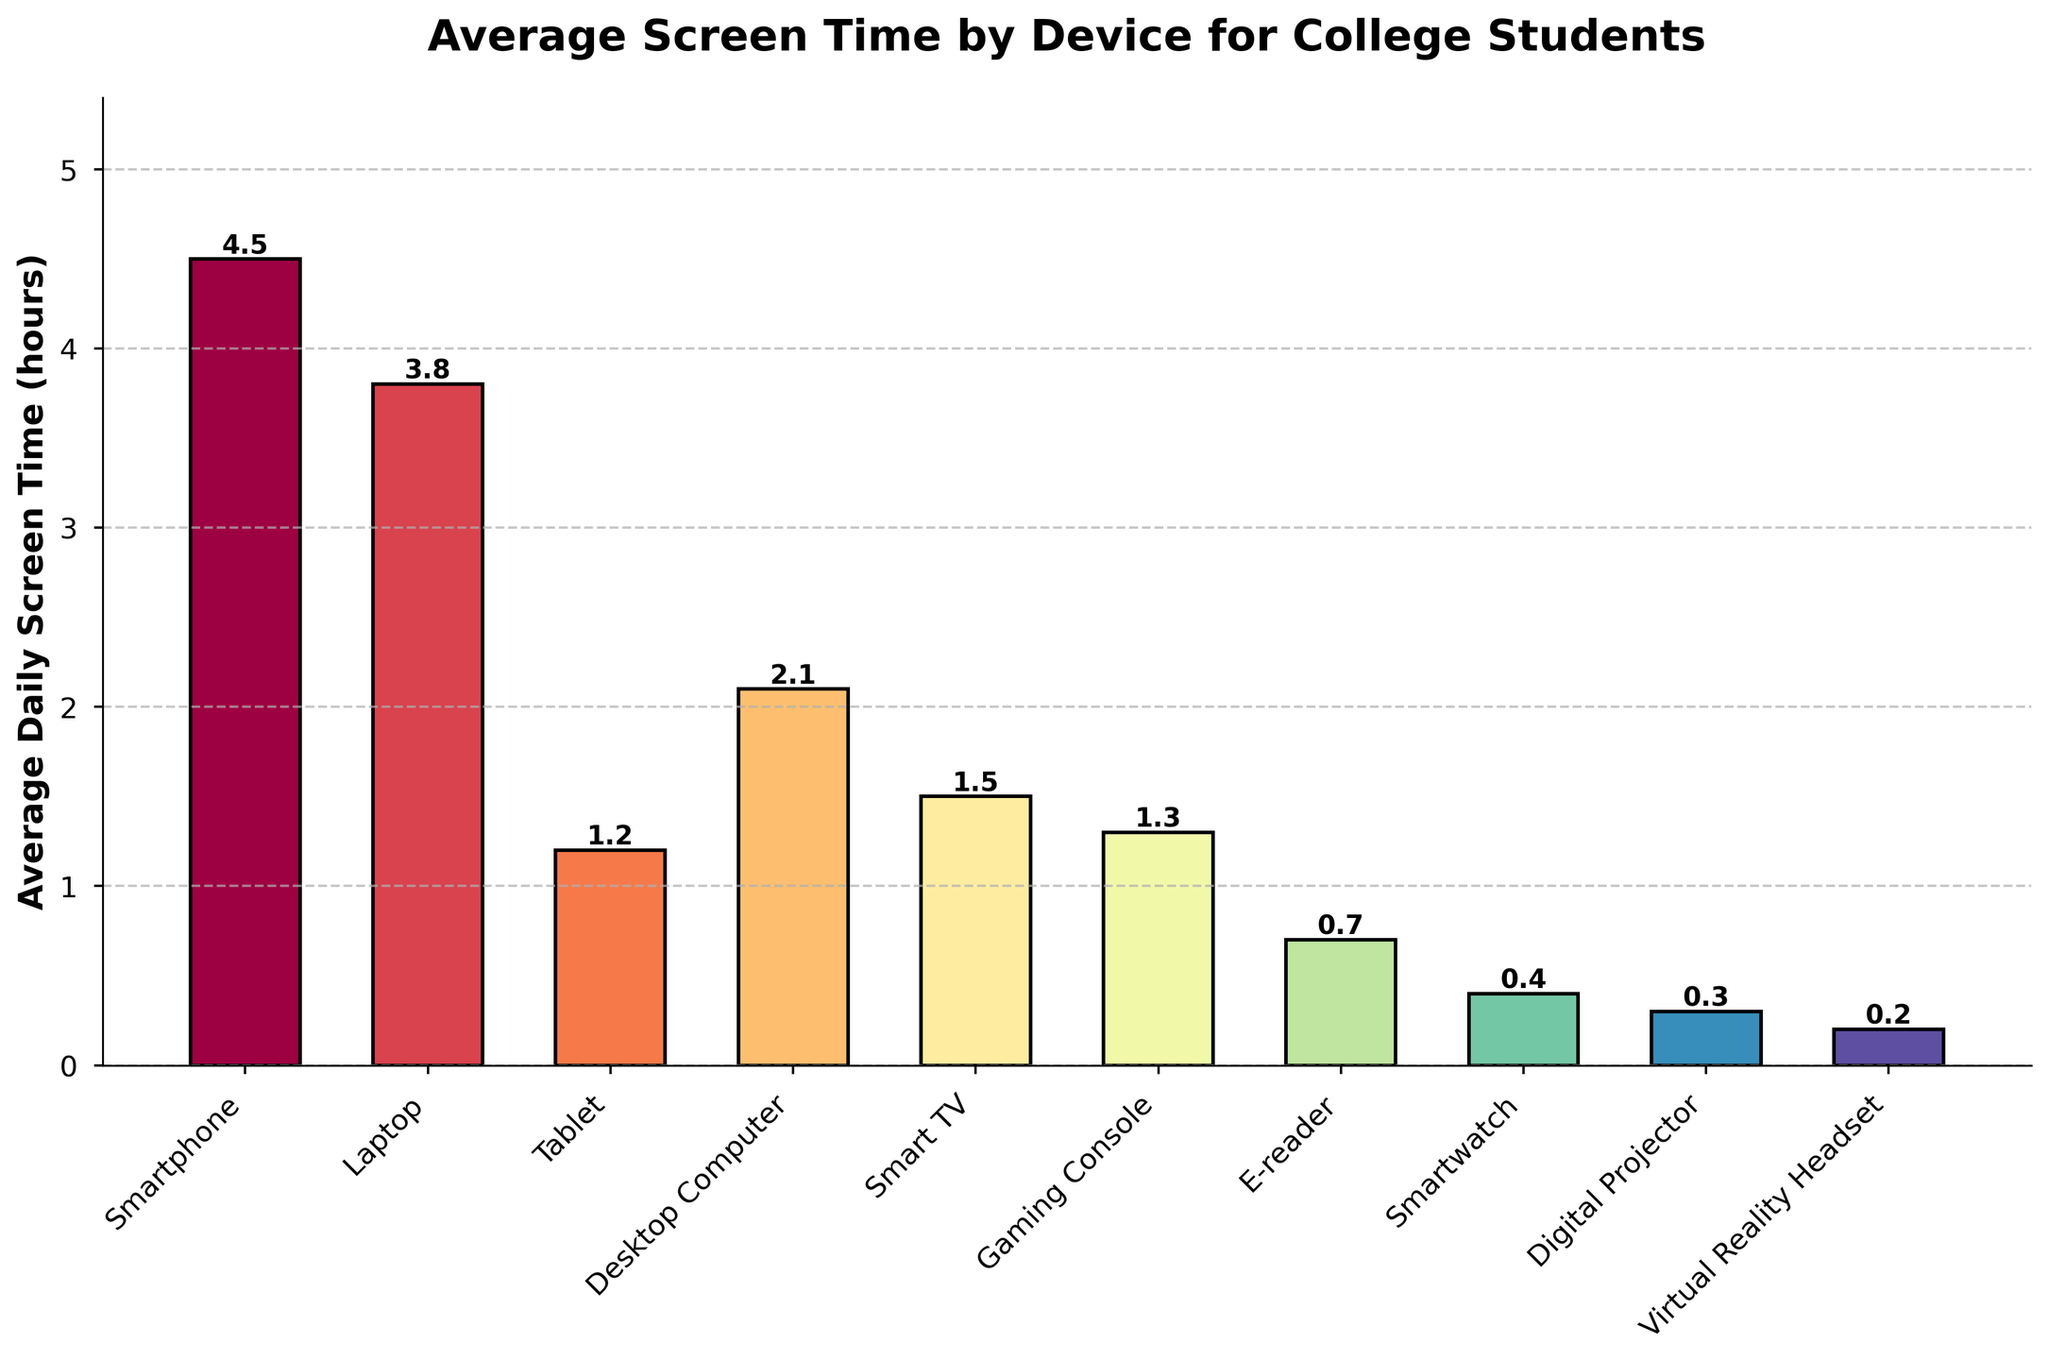How much more screen time do college students spend on their laptops compared to their tablets? First, observe the average daily screen time for both devices: laptops (3.8 hours) and tablets (1.2 hours). Then subtract the tablet's screen time from the laptop's screen time: 3.8 - 1.2.
Answer: 2.6 Which device has the highest average screen time? Look at the height of the bars to determine which one is the tallest. The device associated with the tallest bar represents the highest average screen time. The tallest bar corresponds to the Smartphone.
Answer: Smartphone What is the combined daily screen time for Smart TVs, Gaming Consoles, and E-readers? Identify and sum the average daily screen times for each device: Smart TV (1.5 hours), Gaming Console (1.3 hours), and E-reader (0.7 hours). Sum them: 1.5 + 1.3 + 0.7.
Answer: 3.5 How does the average screen time for Desktop Computers compare to Smart TVs? Compare the average daily screen time values for Desktop Computers (2.1 hours) and Smart TVs (1.5 hours). Desktop Computers have more screen time than Smart TVs.
Answer: Desktop Computers have more screen time What is the percentage share of screen time for Smartwatches out of the total screen time for all devices? First, calculate the total screen time for all devices: 4.5 (Smartphone) + 3.8 (Laptop) + 1.2 (Tablet) + 2.1 (Desktop Computer) + 1.5 (Smart TV) + 1.3 (Gaming Console) + 0.7 (E-reader) + 0.4 (Smartwatch) + 0.3 (Digital Projector) + 0.2 (VR Headset) = 15.0 hours. Then, compute the percentage share for Smartwatches: (0.4 / 15.0) * 100.
Answer: 2.67% Rank the top three devices in terms of average screen time. Examine the height of the bars to determine the average screen time for each device. Identify the top three devices starting with the tallest bars: Smartphone (4.5 hours), Laptop (3.8 hours), and Desktop Computer (2.1 hours).
Answer: Smartphone, Laptop, Desktop Computer How much total screen time do college students spend on all devices combined? Sum the average daily screen times for all devices: 4.5 (Smartphone) + 3.8 (Laptop) + 1.2 (Tablet) + 2.1 (Desktop Computer) + 1.5 (Smart TV) + 1.3 (Gaming Console) + 0.7 (E-reader) + 0.4 (Smartwatch) + 0.3 (Digital Projector) + 0.2 (VR Headset). Add them up: 4.5 + 3.8 + 1.2 + 2.1 + 1.5 + 1.3 + 0.7 + 0.4 + 0.3 + 0.2.
Answer: 15.0 hours Which device has the lowest average screen time and what is the time? Identify the shortest bar in the plot, which represents the device with the lowest average screen time. This corresponds to the Virtual Reality Headset.
Answer: Virtual Reality Headset, 0.2 hours 